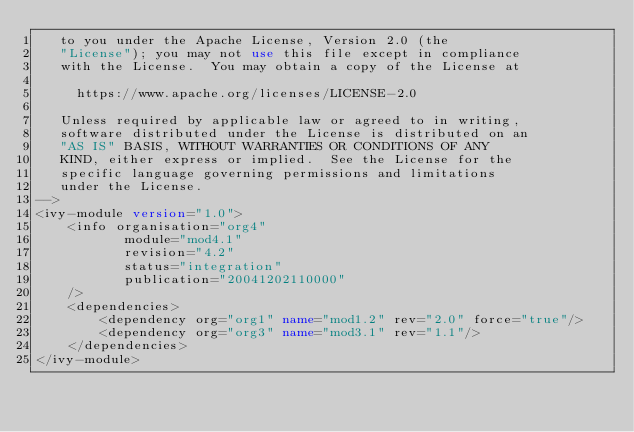<code> <loc_0><loc_0><loc_500><loc_500><_XML_>   to you under the Apache License, Version 2.0 (the
   "License"); you may not use this file except in compliance
   with the License.  You may obtain a copy of the License at

     https://www.apache.org/licenses/LICENSE-2.0

   Unless required by applicable law or agreed to in writing,
   software distributed under the License is distributed on an
   "AS IS" BASIS, WITHOUT WARRANTIES OR CONDITIONS OF ANY
   KIND, either express or implied.  See the License for the
   specific language governing permissions and limitations
   under the License.    
-->
<ivy-module version="1.0">
	<info organisation="org4"
	       module="mod4.1"
	       revision="4.2"
	       status="integration"
	       publication="20041202110000"
	/>
	<dependencies>
		<dependency org="org1" name="mod1.2" rev="2.0" force="true"/>
		<dependency org="org3" name="mod3.1" rev="1.1"/>
	</dependencies>
</ivy-module>
</code> 